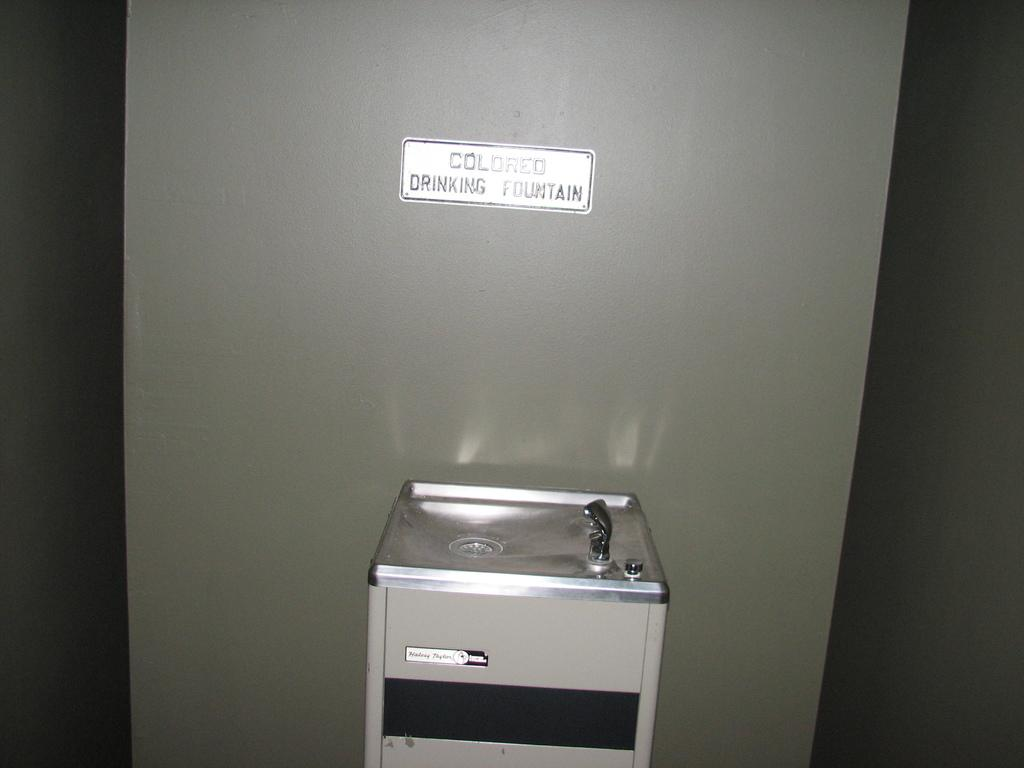<image>
Write a terse but informative summary of the picture. The sign over the water fountain states that it is the colored drinking fountain. 